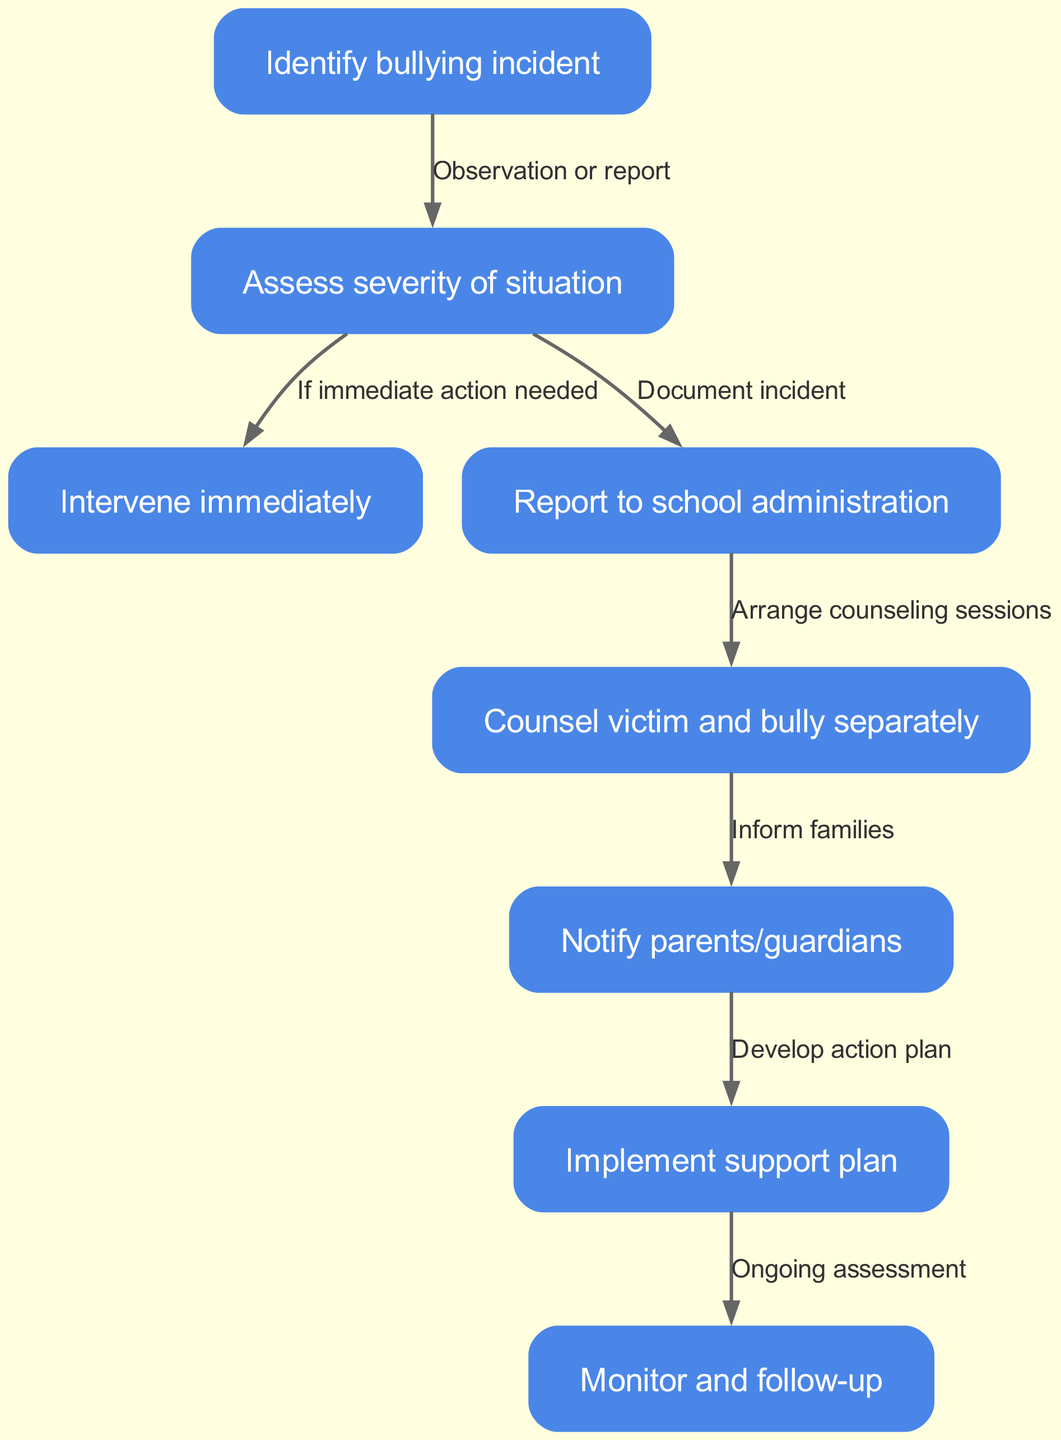What is the first step in the bullying prevention protocol? The diagram lists "Identify bullying incident" as the first node. This is confirmed by the order of nodes, where "Identify bullying incident" appears at the beginning of the flow.
Answer: Identify bullying incident How many nodes are in the diagram? By counting the nodes listed in the diagram, there are a total of eight nodes. This can be verified by noting each node defined in the data.
Answer: 8 What action follows assessing the severity of the situation? The diagram indicates that after "Assess severity of situation," the next action is "Intervene immediately" if immediate action is needed, as represented by the directed edge connecting these two nodes.
Answer: Intervene immediately What happens after reporting to school administration? After "Report to school administration," the next step is to "Counsel victim and bully separately," as shown by the directed edge originating from the reporting node pointing to the counseling node.
Answer: Counsel victim and bully separately What relationship is described between identifying a bullying incident and assessing its severity? The relationship is described as "Observation or report," indicating that identifying the incident leads to assessing its severity either through direct observation or a report made by bystanders.
Answer: Observation or report What is the final step in the bullying prevention protocol? The last node in the diagram is labeled "Monitor and follow-up," which represents the final step in the process after implementing the support plan.
Answer: Monitor and follow-up What is the purpose of notifying parents/guardians? The action of notifying parents/guardians is linked to developing an action plan, which involves informing families about the incident to foster cooperation in addressing the situation.
Answer: Inform families How many edges connect the nodes in the diagram? By counting the edges defined in the diagram, there are a total of seven edges, each representing the directional relationship between the connected nodes.
Answer: 7 What indicates the need for immediate intervention in the protocol? The protocol states that immediate intervention is needed "If immediate action needed," which appears as a conditional statement connecting assessing severity to intervening immediately.
Answer: If immediate action needed 